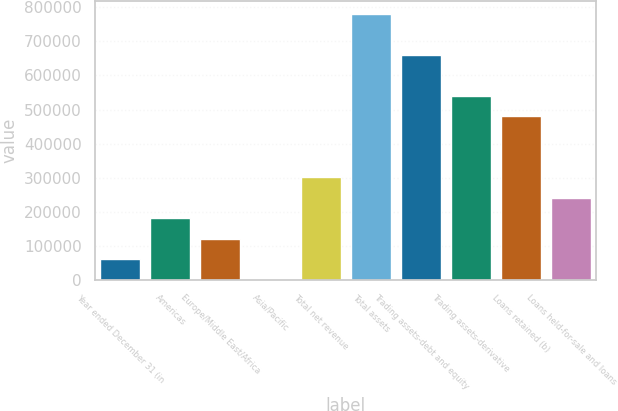Convert chart to OTSL. <chart><loc_0><loc_0><loc_500><loc_500><bar_chart><fcel>Year ended December 31 (in<fcel>Americas<fcel>Europe/Middle East/Africa<fcel>Asia/Pacific<fcel>Total net revenue<fcel>Total assets<fcel>Trading assets-debt and equity<fcel>Trading assets-derivative<fcel>Loans retained (b)<fcel>Loans held-for-sale and loans<nl><fcel>61575.4<fcel>181172<fcel>121374<fcel>1777<fcel>300769<fcel>779156<fcel>659559<fcel>539963<fcel>480164<fcel>240971<nl></chart> 